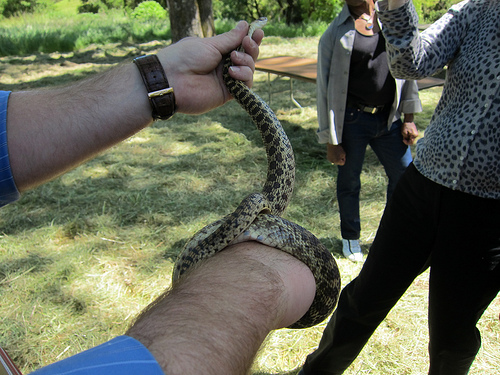<image>
Can you confirm if the watch is to the left of the snake? Yes. From this viewpoint, the watch is positioned to the left side relative to the snake. 